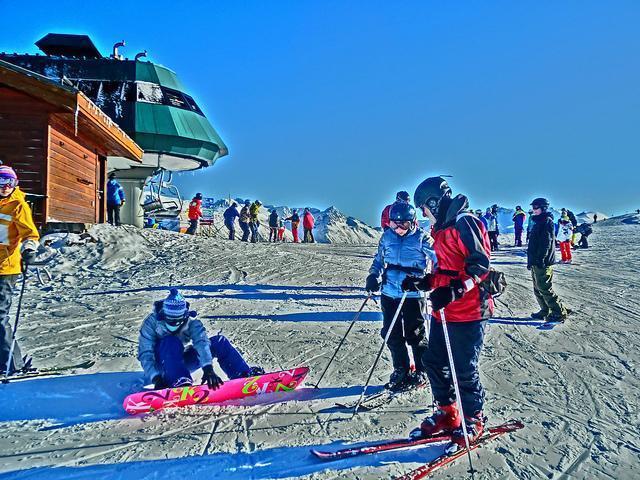How many people are sitting?
Give a very brief answer. 1. How many people can be seen?
Give a very brief answer. 6. 